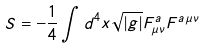<formula> <loc_0><loc_0><loc_500><loc_500>S = - \frac { 1 } { 4 } \int d ^ { 4 } x \sqrt { | g | } F ^ { a } _ { \mu \nu } F ^ { a \, \mu \nu }</formula> 